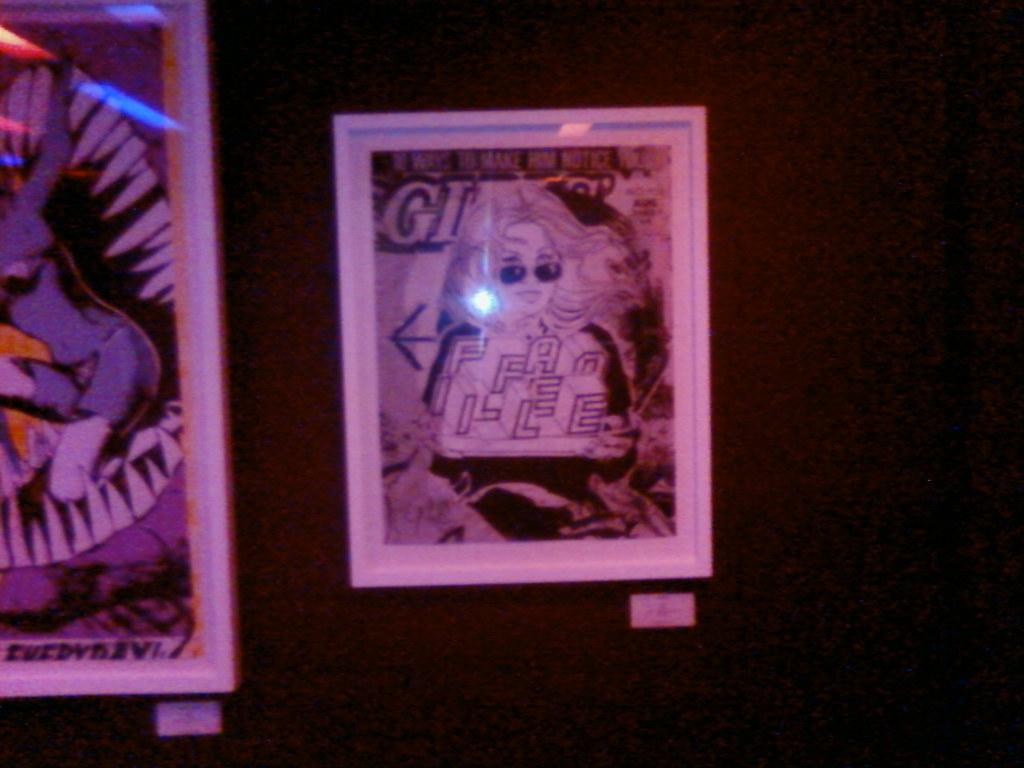<image>
Provide a brief description of the given image. A picture of a woman has letters on her shirt, including "F" and "A". 